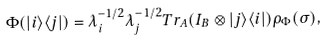<formula> <loc_0><loc_0><loc_500><loc_500>\Phi ( | i \rangle \langle j | ) = \lambda _ { i } ^ { - 1 / 2 } \lambda _ { j } ^ { - 1 / 2 } T r _ { A } ( I _ { B } \otimes | j \rangle \langle i | ) \rho _ { \Phi } ( \sigma ) ,</formula> 